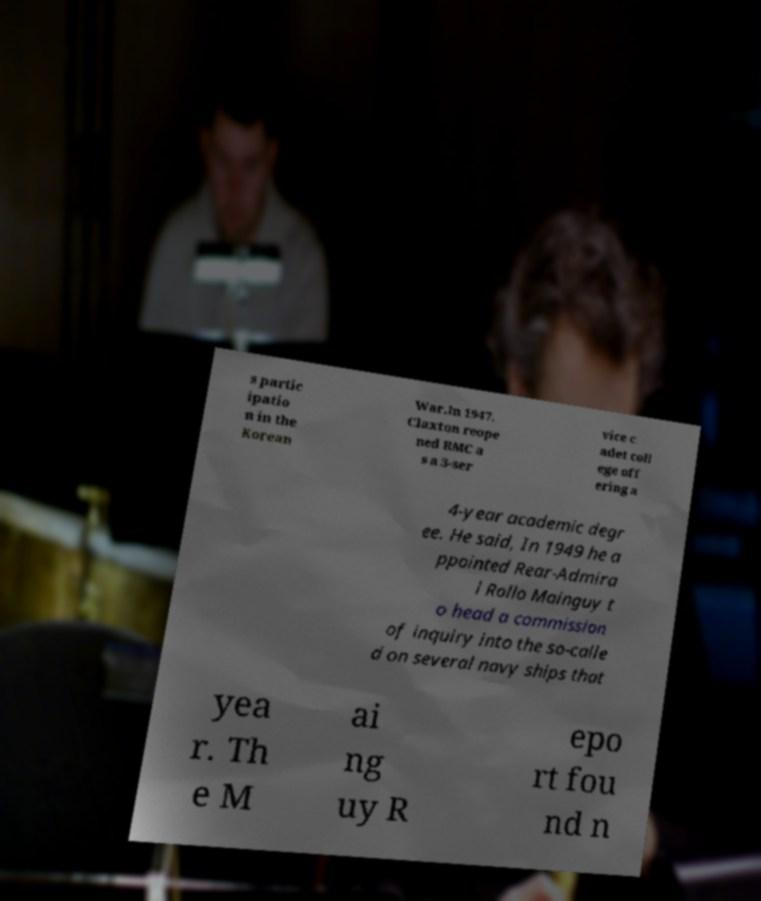What messages or text are displayed in this image? I need them in a readable, typed format. s partic ipatio n in the Korean War.In 1947, Claxton reope ned RMC a s a 3-ser vice c adet coll ege off ering a 4-year academic degr ee. He said, In 1949 he a ppointed Rear-Admira l Rollo Mainguy t o head a commission of inquiry into the so-calle d on several navy ships that yea r. Th e M ai ng uy R epo rt fou nd n 